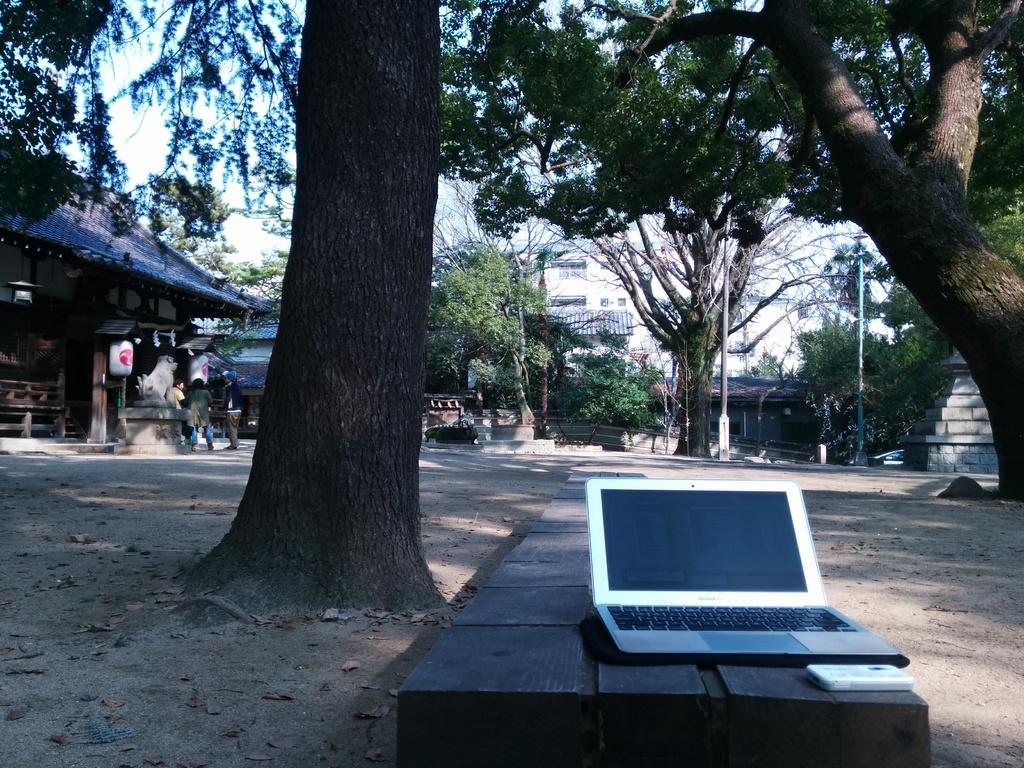What electronic device is visible in the image? There is a laptop in the image. What can be seen in the background of the image? There are trees, people, and the sky visible in the background of the image. What is the color of the trees in the image? The trees are green in the image. What is the color of the sky in the image? The sky is white in the image. Where is the kettle located in the image? There is no kettle present in the image. What type of collar is visible on the trees in the image? There are no collars present on the trees in the image; they are simply green trees. 